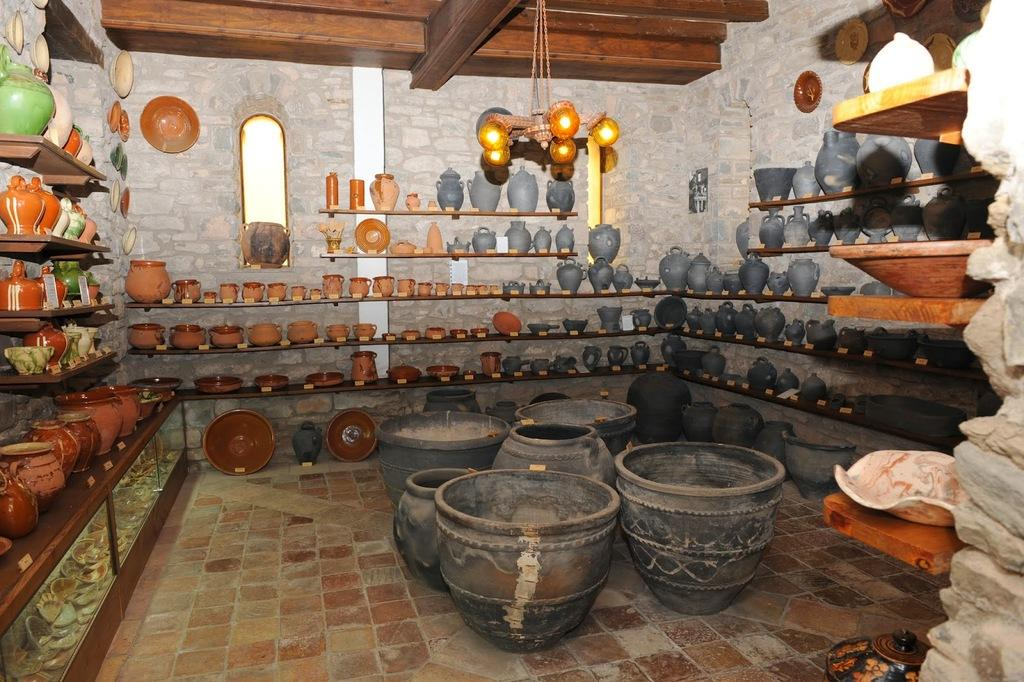What can be seen on the shelves in the image? There are objects arranged on shelves in the image. What is visible in the background of the image? There is a wall and a mirror in the background of the image. Where is the light located in the image? The light is at the top of the image. Who is the owner of the mirror in the image? There is no information about the owner of the mirror in the image. Is there a basin visible in the image? No, there is no basin present in the image. 